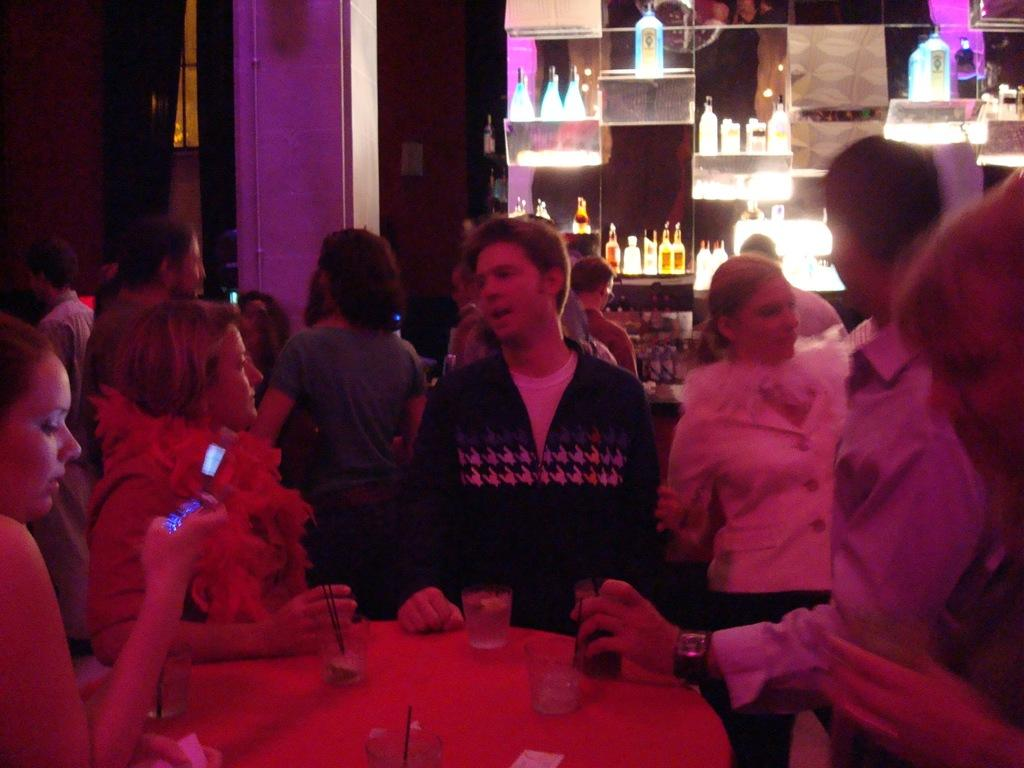What objects can be seen in the image? There are bottles in the image. Are there any people present in the image? Yes, there are people standing in the image. What piece of furniture is visible in the image? There is a table in the image. What can be found on the table? There are glasses on the table. Can you see any cars in the image? No, there are no cars present in the image. Are there any toes visible in the image? No, there are no toes visible in the image. 